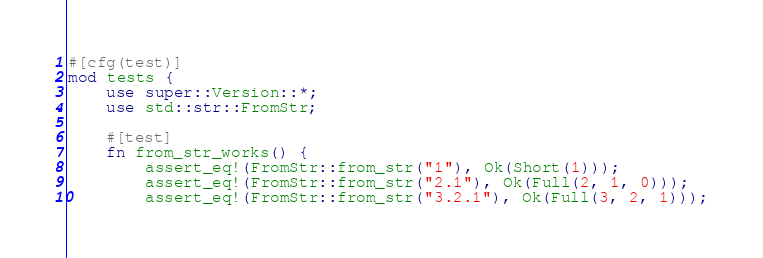Convert code to text. <code><loc_0><loc_0><loc_500><loc_500><_Rust_>#[cfg(test)]
mod tests {
    use super::Version::*;
    use std::str::FromStr;

    #[test]
    fn from_str_works() {
        assert_eq!(FromStr::from_str("1"), Ok(Short(1)));
        assert_eq!(FromStr::from_str("2.1"), Ok(Full(2, 1, 0)));
        assert_eq!(FromStr::from_str("3.2.1"), Ok(Full(3, 2, 1)));</code> 